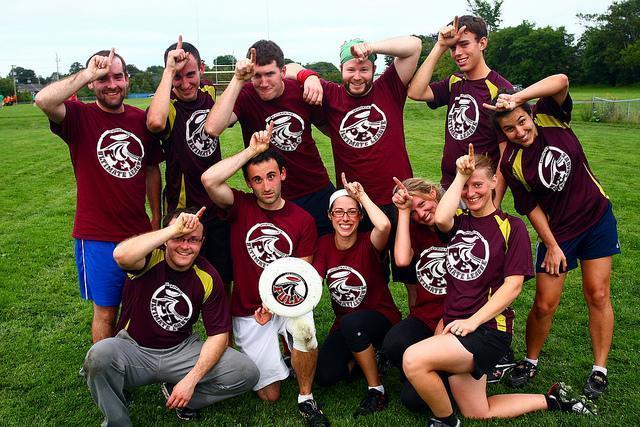How many people are there?
Give a very brief answer. 11. 